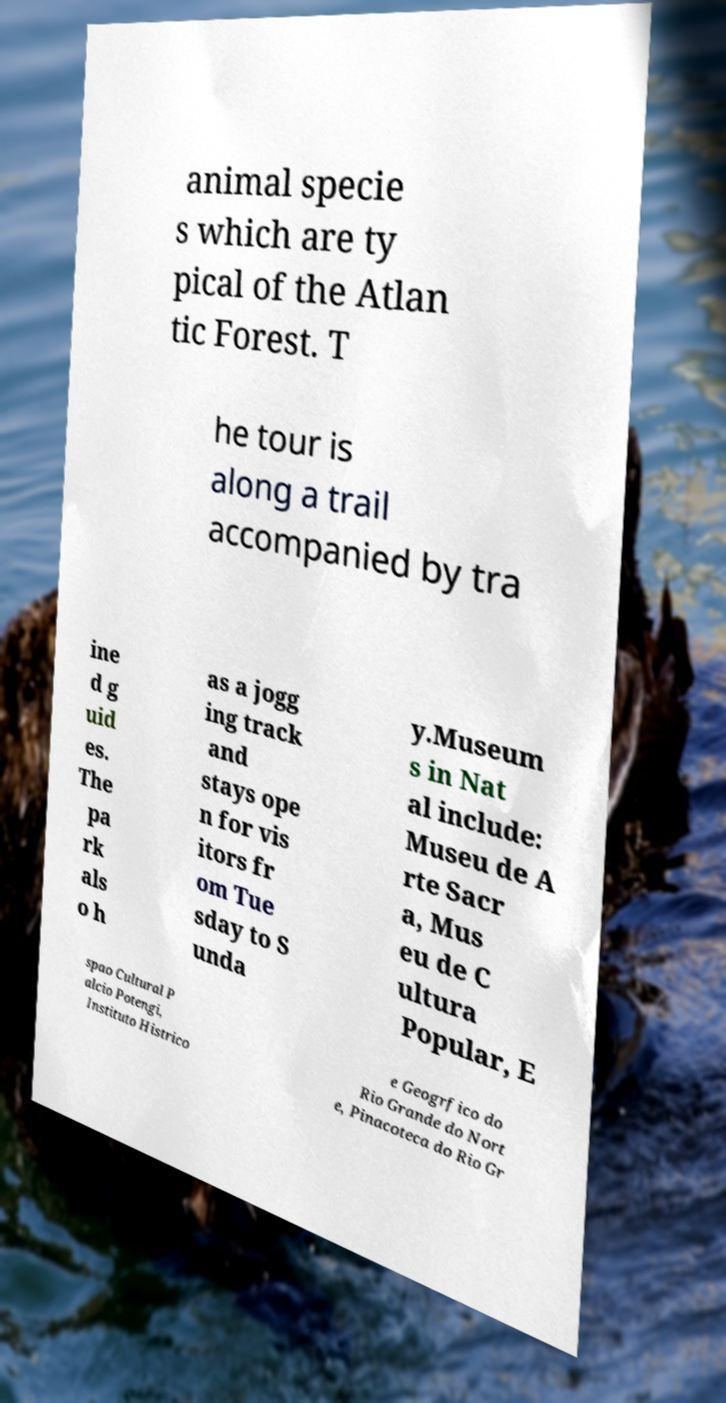What messages or text are displayed in this image? I need them in a readable, typed format. animal specie s which are ty pical of the Atlan tic Forest. T he tour is along a trail accompanied by tra ine d g uid es. The pa rk als o h as a jogg ing track and stays ope n for vis itors fr om Tue sday to S unda y.Museum s in Nat al include: Museu de A rte Sacr a, Mus eu de C ultura Popular, E spao Cultural P alcio Potengi, Instituto Histrico e Geogrfico do Rio Grande do Nort e, Pinacoteca do Rio Gr 